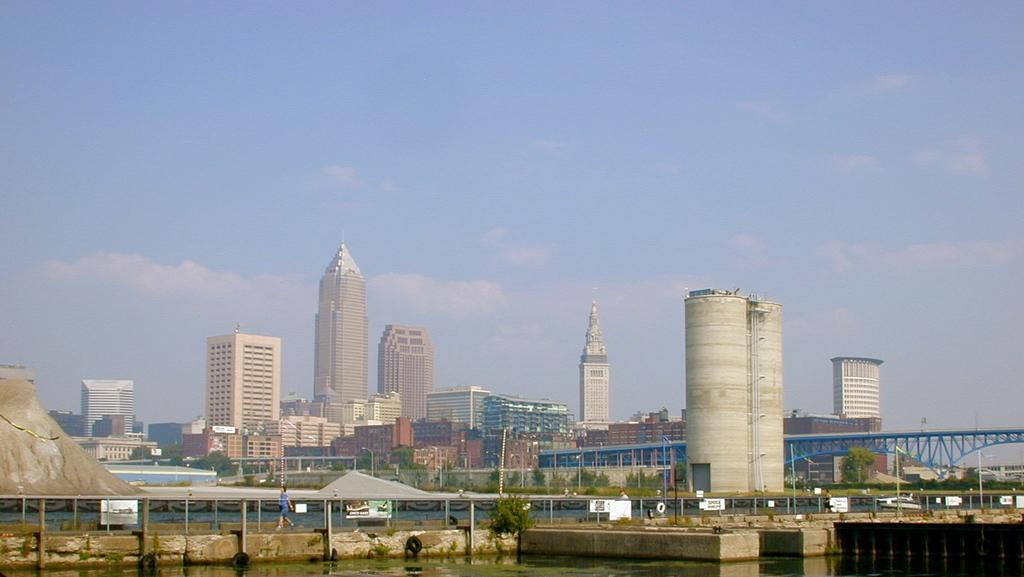What type of structures can be seen in the image? There are buildings in the image. What natural feature is present in the image? There is a river in the image. What connects the two sides of the river in the image? There is a bridge over the river on the right side. What can be seen in the sky in the background of the image? There are clouds in the sky in the background of the image. What type of quilt is being used to cover the society in the image? There is no quilt or society present in the image. How many bags can be seen hanging from the bridge in the image? There are no bags present on the bridge in the image. 